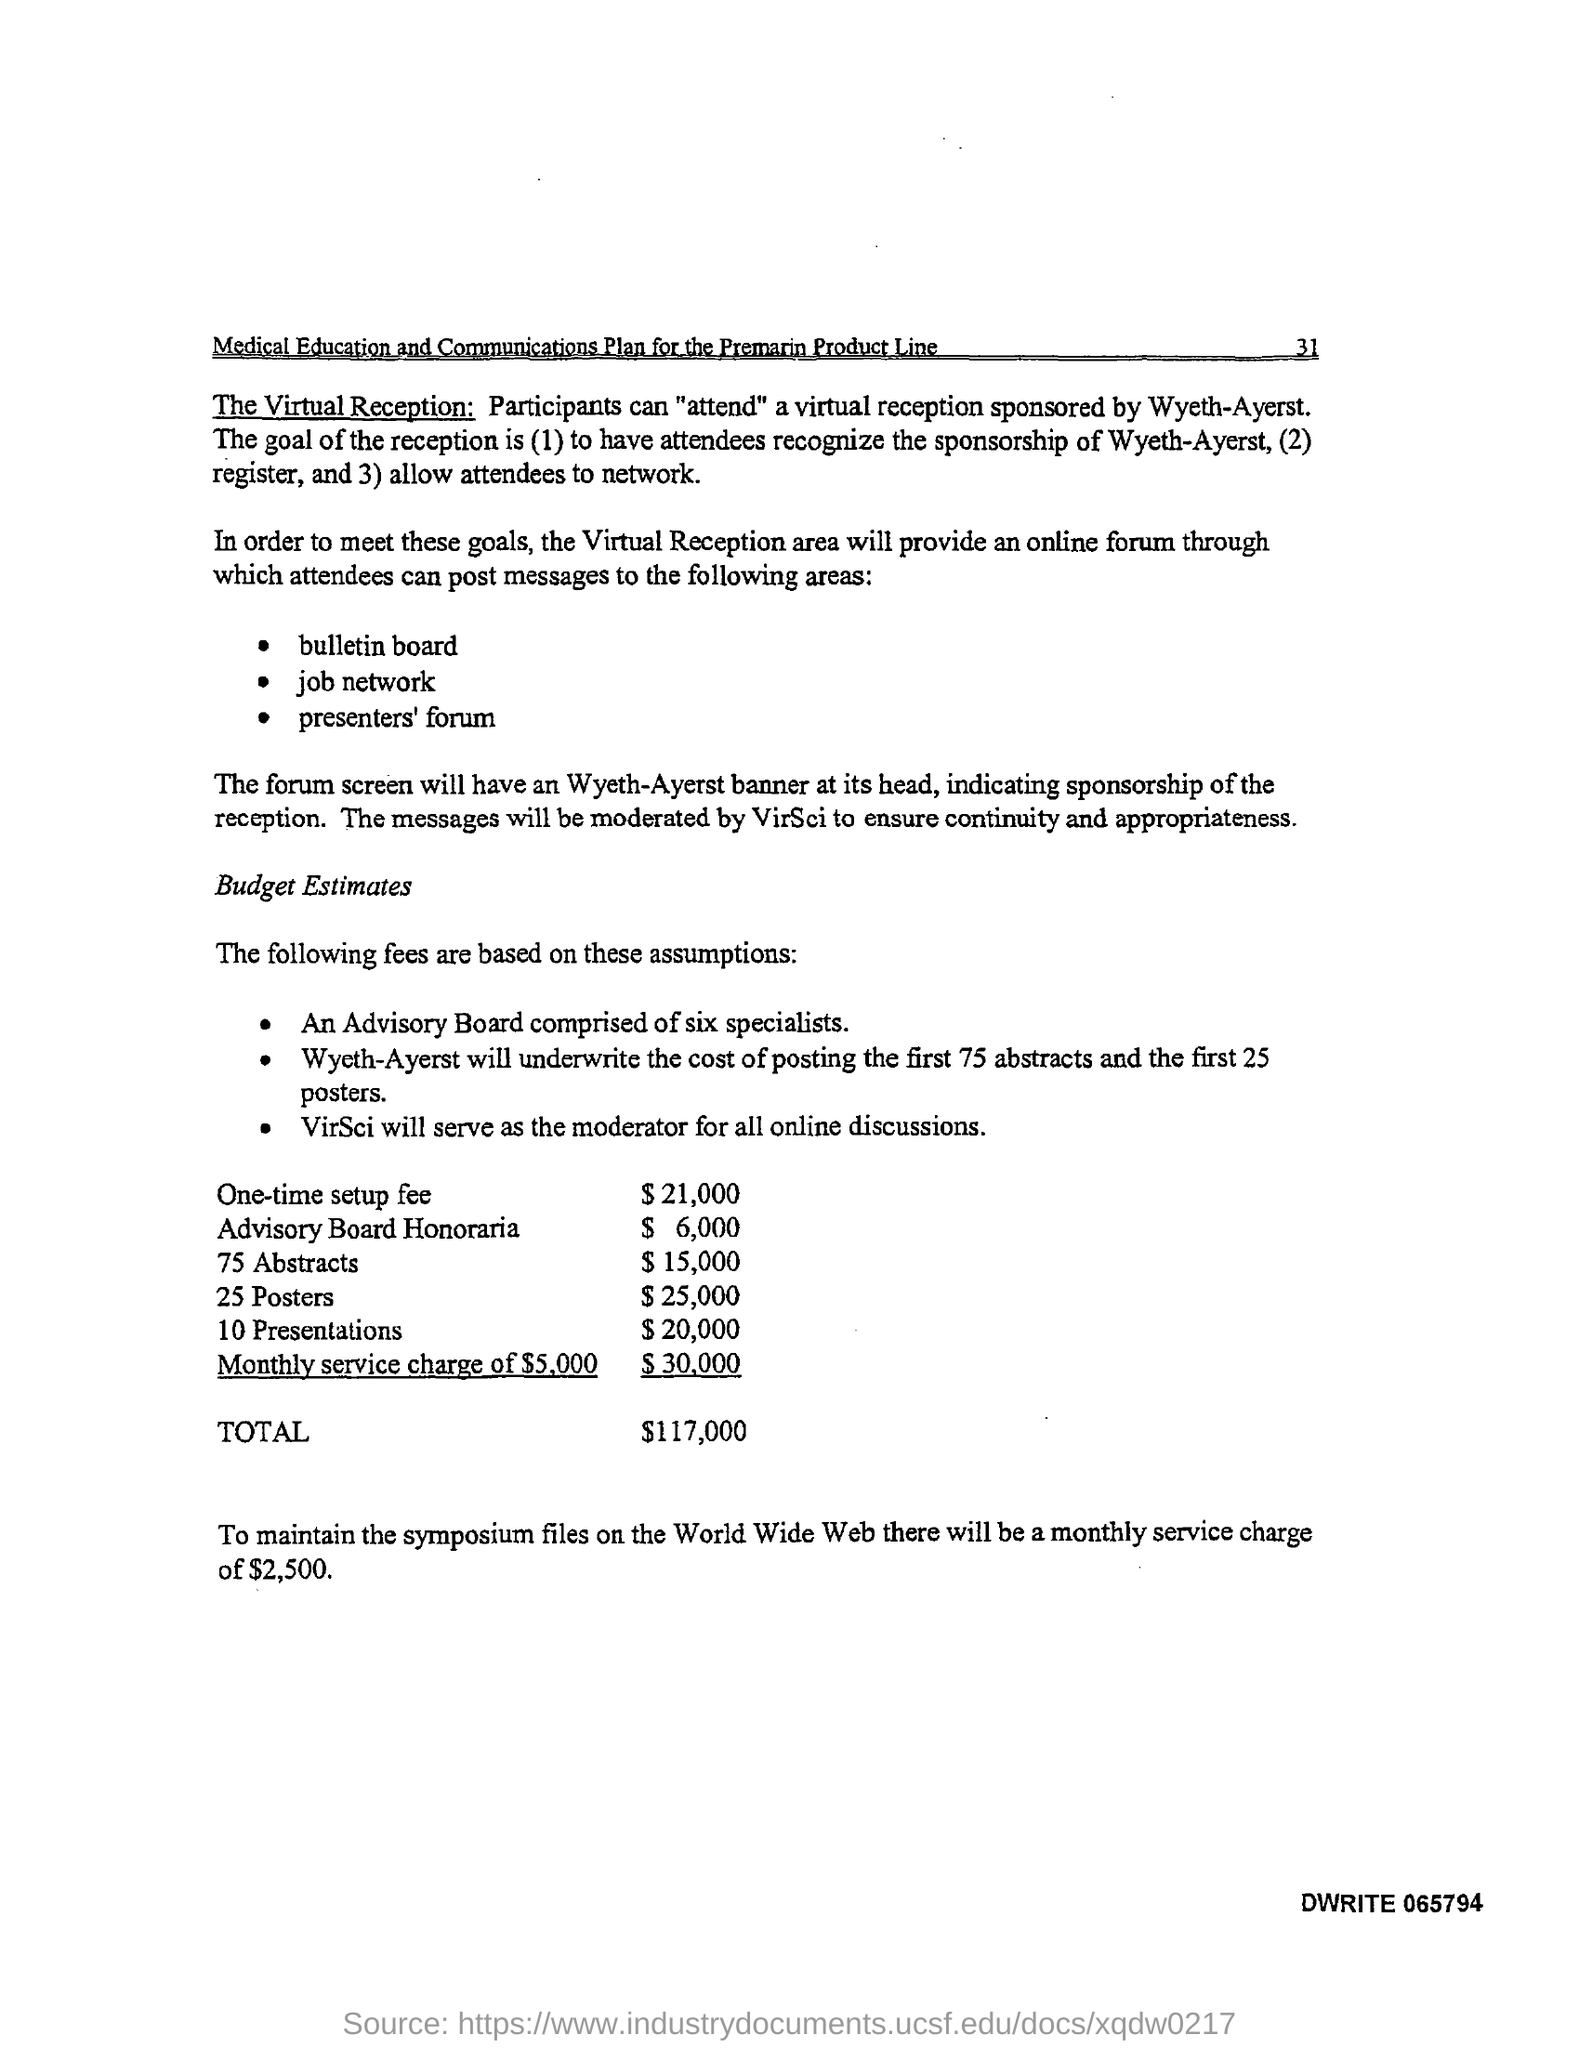Who sponsored this product?
Offer a terse response. Wyeth-Ayerst. 